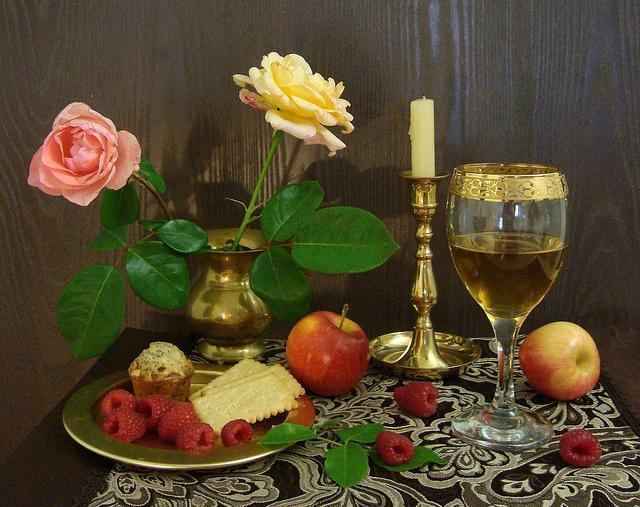How many apples are in the photo?
Give a very brief answer. 2. How many people are to the left of the cats?
Give a very brief answer. 0. 